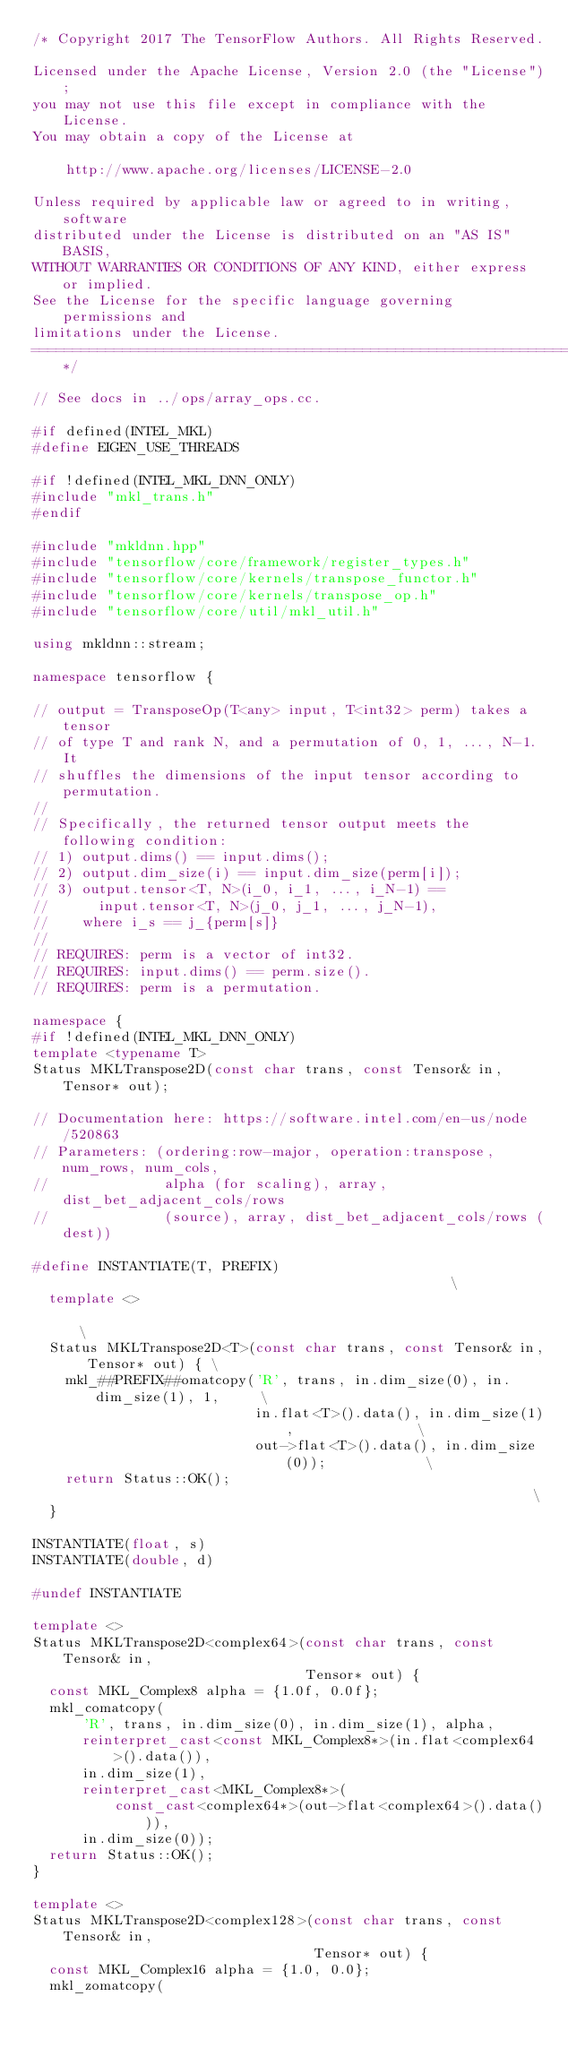<code> <loc_0><loc_0><loc_500><loc_500><_C++_>/* Copyright 2017 The TensorFlow Authors. All Rights Reserved.

Licensed under the Apache License, Version 2.0 (the "License");
you may not use this file except in compliance with the License.
You may obtain a copy of the License at

    http://www.apache.org/licenses/LICENSE-2.0

Unless required by applicable law or agreed to in writing, software
distributed under the License is distributed on an "AS IS" BASIS,
WITHOUT WARRANTIES OR CONDITIONS OF ANY KIND, either express or implied.
See the License for the specific language governing permissions and
limitations under the License.
==============================================================================*/

// See docs in ../ops/array_ops.cc.

#if defined(INTEL_MKL)
#define EIGEN_USE_THREADS

#if !defined(INTEL_MKL_DNN_ONLY)
#include "mkl_trans.h"
#endif

#include "mkldnn.hpp"
#include "tensorflow/core/framework/register_types.h"
#include "tensorflow/core/kernels/transpose_functor.h"
#include "tensorflow/core/kernels/transpose_op.h"
#include "tensorflow/core/util/mkl_util.h"

using mkldnn::stream;

namespace tensorflow {

// output = TransposeOp(T<any> input, T<int32> perm) takes a tensor
// of type T and rank N, and a permutation of 0, 1, ..., N-1. It
// shuffles the dimensions of the input tensor according to permutation.
//
// Specifically, the returned tensor output meets the following condition:
// 1) output.dims() == input.dims();
// 2) output.dim_size(i) == input.dim_size(perm[i]);
// 3) output.tensor<T, N>(i_0, i_1, ..., i_N-1) ==
//      input.tensor<T, N>(j_0, j_1, ..., j_N-1),
//    where i_s == j_{perm[s]}
//
// REQUIRES: perm is a vector of int32.
// REQUIRES: input.dims() == perm.size().
// REQUIRES: perm is a permutation.

namespace {
#if !defined(INTEL_MKL_DNN_ONLY)
template <typename T>
Status MKLTranspose2D(const char trans, const Tensor& in, Tensor* out);

// Documentation here: https://software.intel.com/en-us/node/520863
// Parameters: (ordering:row-major, operation:transpose, num_rows, num_cols,
//              alpha (for scaling), array, dist_bet_adjacent_cols/rows
//              (source), array, dist_bet_adjacent_cols/rows (dest))

#define INSTANTIATE(T, PREFIX)                                                \
  template <>                                                                 \
  Status MKLTranspose2D<T>(const char trans, const Tensor& in, Tensor* out) { \
    mkl_##PREFIX##omatcopy('R', trans, in.dim_size(0), in.dim_size(1), 1,     \
                           in.flat<T>().data(), in.dim_size(1),               \
                           out->flat<T>().data(), in.dim_size(0));            \
    return Status::OK();                                                      \
  }

INSTANTIATE(float, s)
INSTANTIATE(double, d)

#undef INSTANTIATE

template <>
Status MKLTranspose2D<complex64>(const char trans, const Tensor& in,
                                 Tensor* out) {
  const MKL_Complex8 alpha = {1.0f, 0.0f};
  mkl_comatcopy(
      'R', trans, in.dim_size(0), in.dim_size(1), alpha,
      reinterpret_cast<const MKL_Complex8*>(in.flat<complex64>().data()),
      in.dim_size(1),
      reinterpret_cast<MKL_Complex8*>(
          const_cast<complex64*>(out->flat<complex64>().data())),
      in.dim_size(0));
  return Status::OK();
}

template <>
Status MKLTranspose2D<complex128>(const char trans, const Tensor& in,
                                  Tensor* out) {
  const MKL_Complex16 alpha = {1.0, 0.0};
  mkl_zomatcopy(</code> 